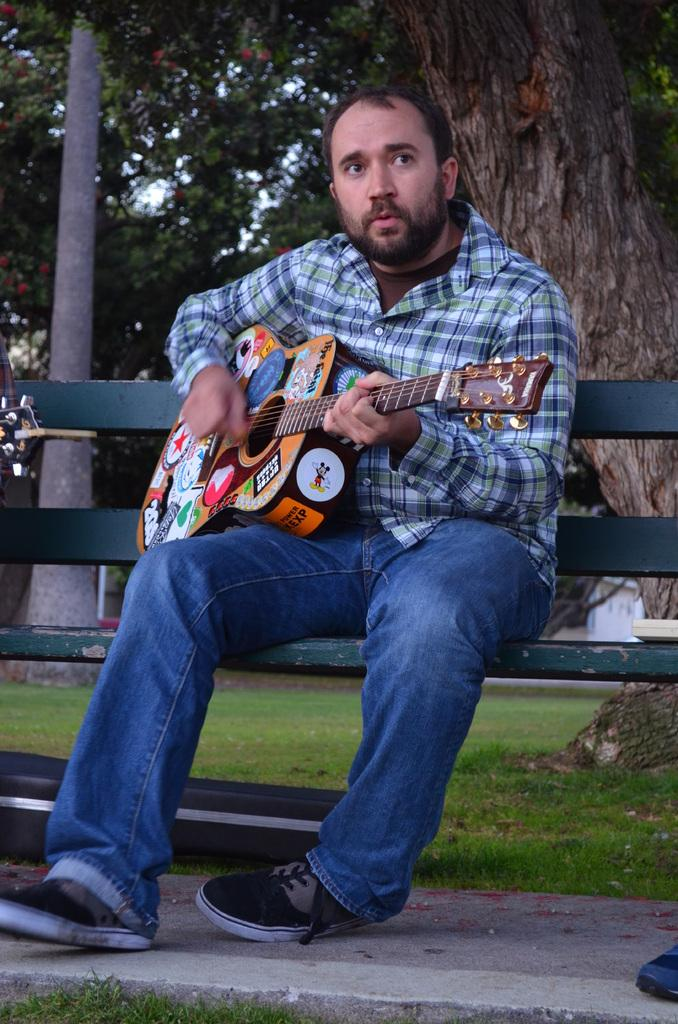What is the man in the image doing? The man is playing the guitar. What is the man sitting on in the image? The man is sitting on a bench. What type of clothing is the man wearing? The man is wearing a shirt, trousers, and shoes. What can be seen in the background of the image? There are trees behind the man. What type of drum is the man playing in the image? There is no drum present in the image; the man is playing the guitar. How does the donkey contribute to the man's musical performance in the image? There is no donkey present in the image, so it cannot contribute to the man's musical performance. 